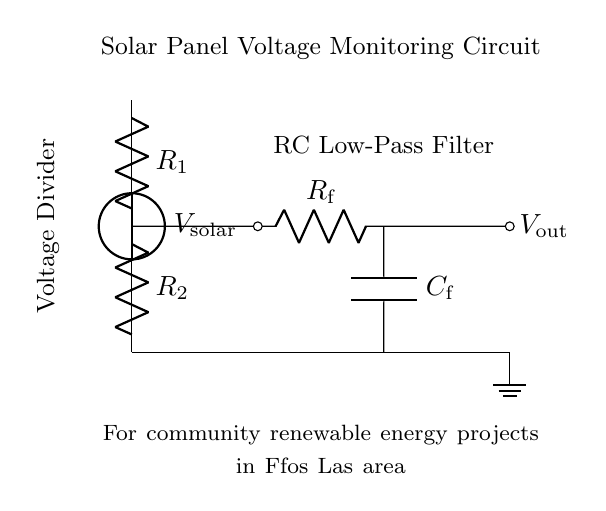What is the purpose of the voltage divider in this circuit? The voltage divider is used to reduce the voltage from the solar panel to a lower level appropriate for measurement. It consists of two resistors, R1 and R2, which share the input voltage based on their resistance values.
Answer: reduce voltage What is the role of the capacitor in this circuit? The capacitor forms a low-pass filter with the resistor Rf to smooth out voltage variations and provide a stable output voltage that reflects the average solar panel output over time.
Answer: smooth output What components are in the voltage divider portion of the circuit? The voltage divider consists of two resistors, R1 and R2, which are connected in series across the solar panel's voltage output.
Answer: R1 and R2 What is the output voltage labeled in the circuit? The output voltage, labeled Vout, is taken from the junction between the two resistors of the voltage divider and leads into the RC filter.
Answer: Vout Why is it important to use an RC low-pass filter in this monitoring circuit? The RC low-pass filter is essential to prevent high-frequency noise from affecting the voltage measurement, allowing only the DC component from the solar panel to be measured more accurately.
Answer: prevent noise 